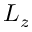Convert formula to latex. <formula><loc_0><loc_0><loc_500><loc_500>L _ { z }</formula> 